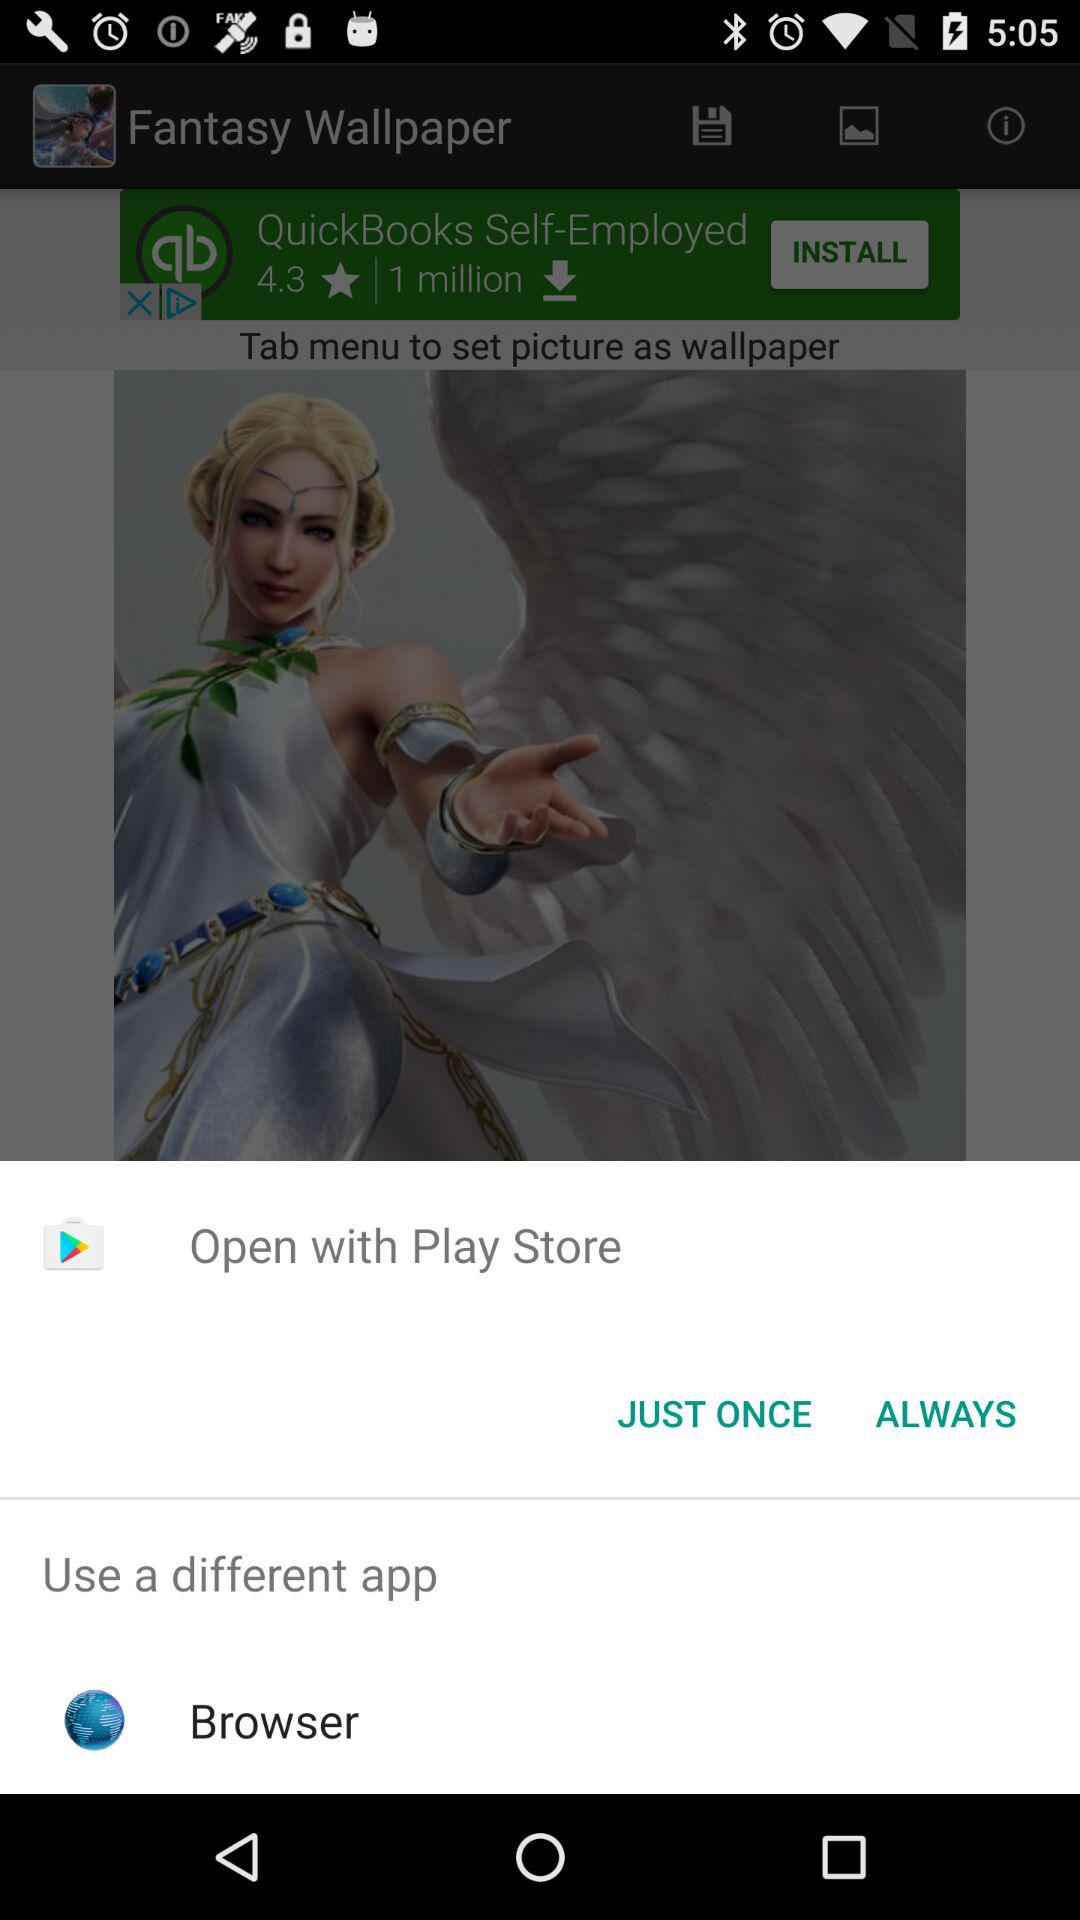What are the different application options we have? The different application option is "Browser". 